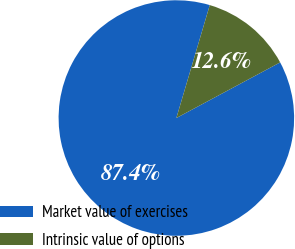Convert chart to OTSL. <chart><loc_0><loc_0><loc_500><loc_500><pie_chart><fcel>Market value of exercises<fcel>Intrinsic value of options<nl><fcel>87.41%<fcel>12.59%<nl></chart> 